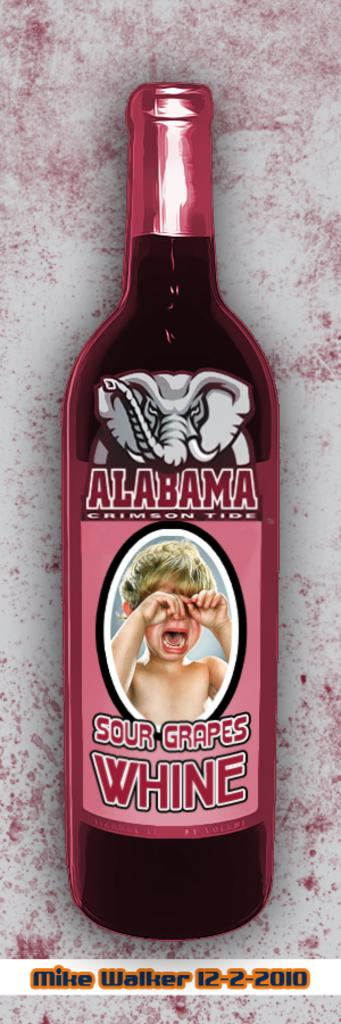<image>
Write a terse but informative summary of the picture. A bottle of red Alabama Sour Grapes Whine 